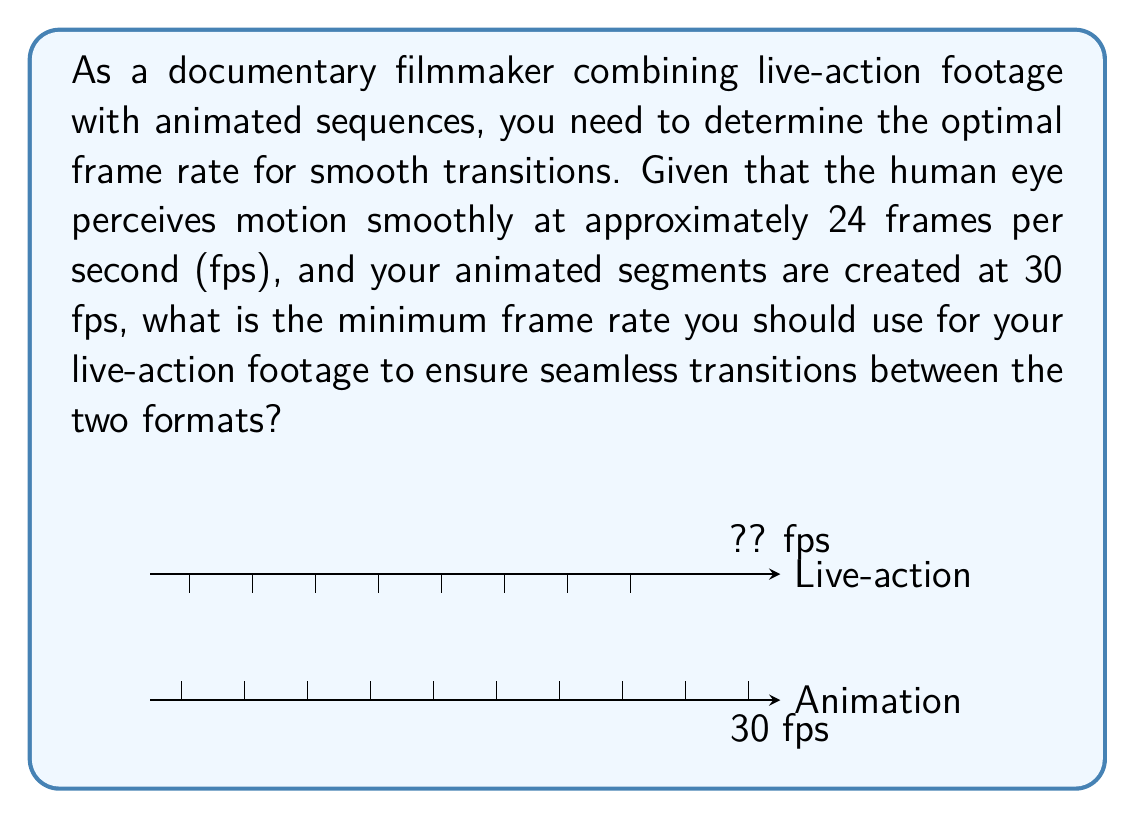What is the answer to this math problem? To solve this problem, we need to consider the following steps:

1) The human eye perceives smooth motion at approximately 24 fps. This is our baseline for smooth transitions.

2) The animated segments are created at 30 fps, which is already above the smooth motion threshold.

3) For seamless transitions, we need to ensure that the live-action footage matches or exceeds the frame rate of the animated segments.

4) The concept of least common multiple (LCM) is useful here. We want to find the smallest frame rate that is divisible by both the animation frame rate and a frame rate suitable for live-action.

5) The LCM of 24 and 30 is:
   $$ LCM(24, 30) = 2^3 \times 3 \times 5 = 120 $$

6) This means that every 120 frames, both the 24 fps and 30 fps sequences will align perfectly.

7) However, 120 fps is unnecessarily high for live-action footage and would require significant storage and processing power.

8) The next lower multiple of 30 that is also above 24 is 30 itself.

Therefore, by setting the live-action footage to 30 fps, we ensure that:
a) It matches the animated segments exactly.
b) It exceeds the threshold for smooth motion perception.
c) It allows for seamless transitions between live-action and animated segments.
Answer: 30 fps 